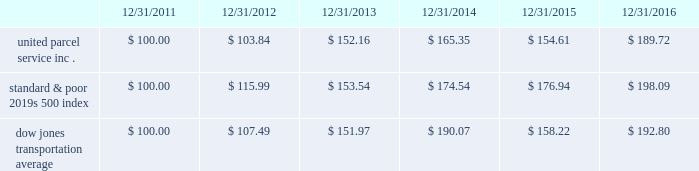Shareowner return performance graph the following performance graph and related information shall not be deemed 201csoliciting material 201d or to be 201cfiled 201d with the sec , nor shall such information be incorporated by reference into any future filing under the securities act of 1933 or securities exchange act of 1934 , each as amended , except to the extent that the company specifically incorporates such information by reference into such filing .
The following graph shows a five year comparison of cumulative total shareowners 2019 returns for our class b common stock , the standard & poor 2019s 500 index and the dow jones transportation average .
The comparison of the total cumulative return on investment , which is the change in the quarterly stock price plus reinvested dividends for each of the quarterly periods , assumes that $ 100 was invested on december 31 , 2011 in the standard & poor 2019s 500 index , the dow jones transportation average and our class b common stock. .

What was the difference in percentage cumulative total shareowners return for united parcel service inc . versus the standard & poor's 500 index for the five years ended 12/31/2016? 
Computations: (((189.72 - 100) / 100) - ((198.09 - 100) / 100))
Answer: -0.0837. 